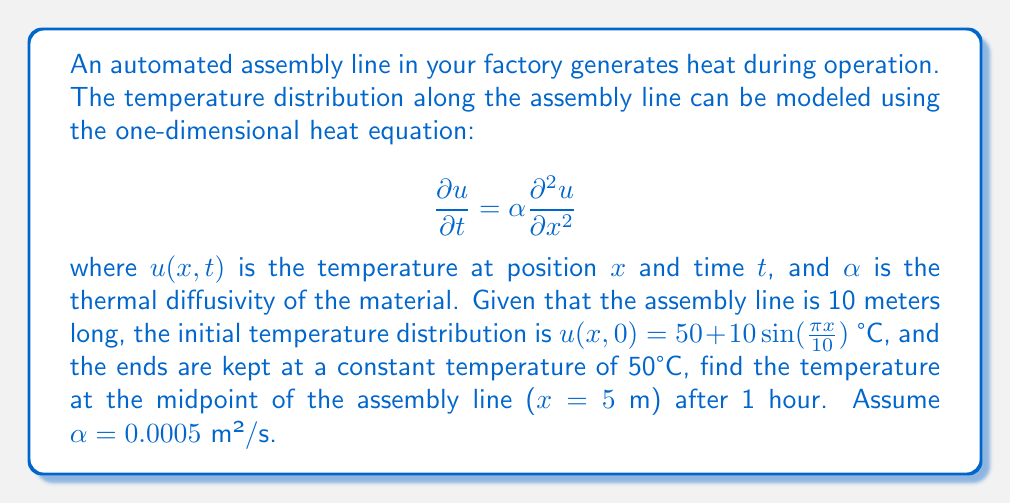Give your solution to this math problem. To solve this problem, we'll use the method of separation of variables for the heat equation with given boundary and initial conditions.

Step 1: Separate variables
Let $u(x,t) = X(x)T(t)$. Substituting into the heat equation:

$$X(x)T'(t) = \alpha X''(x)T(t)$$
$$\frac{T'(t)}{T(t)} = \alpha \frac{X''(x)}{X(x)} = -\lambda$$

where $\lambda$ is a separation constant.

Step 2: Solve for X(x)
$$X''(x) + \frac{\lambda}{\alpha}X(x) = 0$$

With boundary conditions $X(0) = X(10) = 0$, we get:

$$X_n(x) = \sin(\frac{n\pi x}{10}), \quad \lambda_n = (\frac{n\pi}{10})^2\alpha$$

Step 3: Solve for T(t)
$$T'(t) + \lambda_n T(t) = 0$$
$$T_n(t) = e^{-\lambda_n t} = e^{-(\frac{n\pi}{10})^2\alpha t}$$

Step 4: General solution
$$u(x,t) = \sum_{n=1}^{\infty} A_n \sin(\frac{n\pi x}{10}) e^{-(\frac{n\pi}{10})^2\alpha t}$$

Step 5: Apply initial condition
$$u(x,0) = 50 + 10\sin(\frac{\pi x}{10}) = \sum_{n=1}^{\infty} A_n \sin(\frac{n\pi x}{10})$$

Therefore, $A_1 = 10$ and $A_n = 0$ for $n > 1$.

Step 6: Final solution
$$u(x,t) = 50 + 10\sin(\frac{\pi x}{10}) e^{-(\frac{\pi}{10})^2\alpha t}$$

Step 7: Calculate temperature at midpoint after 1 hour
At $x = 5$ m and $t = 3600$ s:

$$u(5,3600) = 50 + 10\sin(\frac{\pi \cdot 5}{10}) e^{-(\frac{\pi}{10})^2 \cdot 0.0005 \cdot 3600}$$
$$= 50 + 10 \cdot 1 \cdot e^{-0.1781}$$
$$= 50 + 10 \cdot 0.8369$$
$$= 58.37 \text{ °C}$$
Answer: 58.37°C 